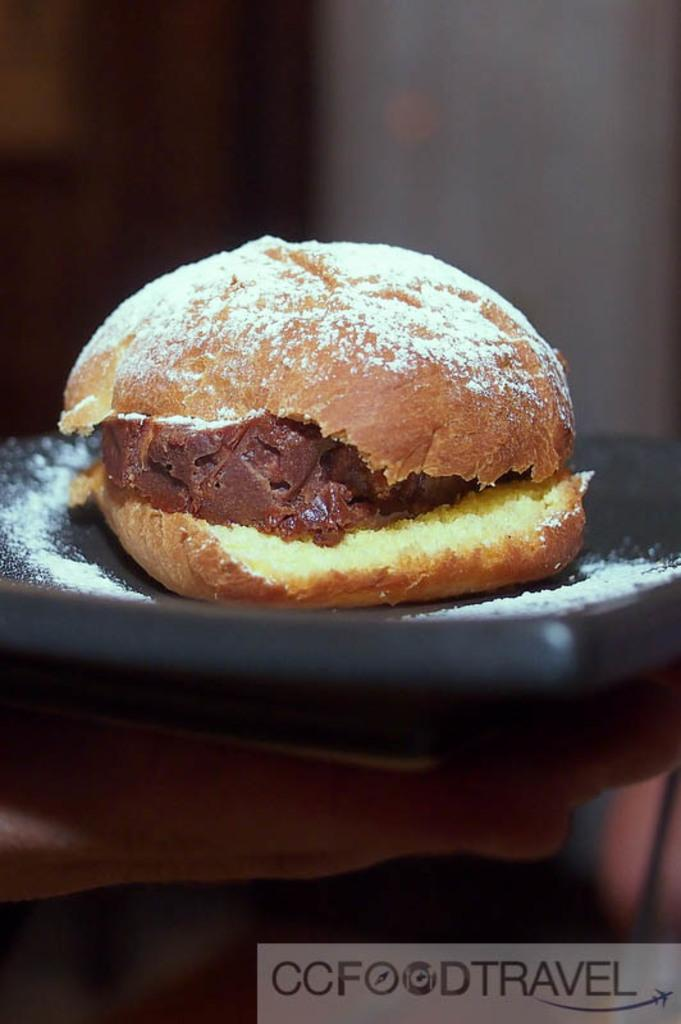What type of food is visible in the image? There is a burger in the image. Where is the burger located? The burger is present in a tray. What can be seen at the right bottom of the image? There is some text at the right bottom of the image. How would you describe the background of the image? The background of the image is blurry. What type of cable is connected to the clock in the image? There is no cable or clock present in the image; it only features a burger in a tray and some text at the right bottom. 